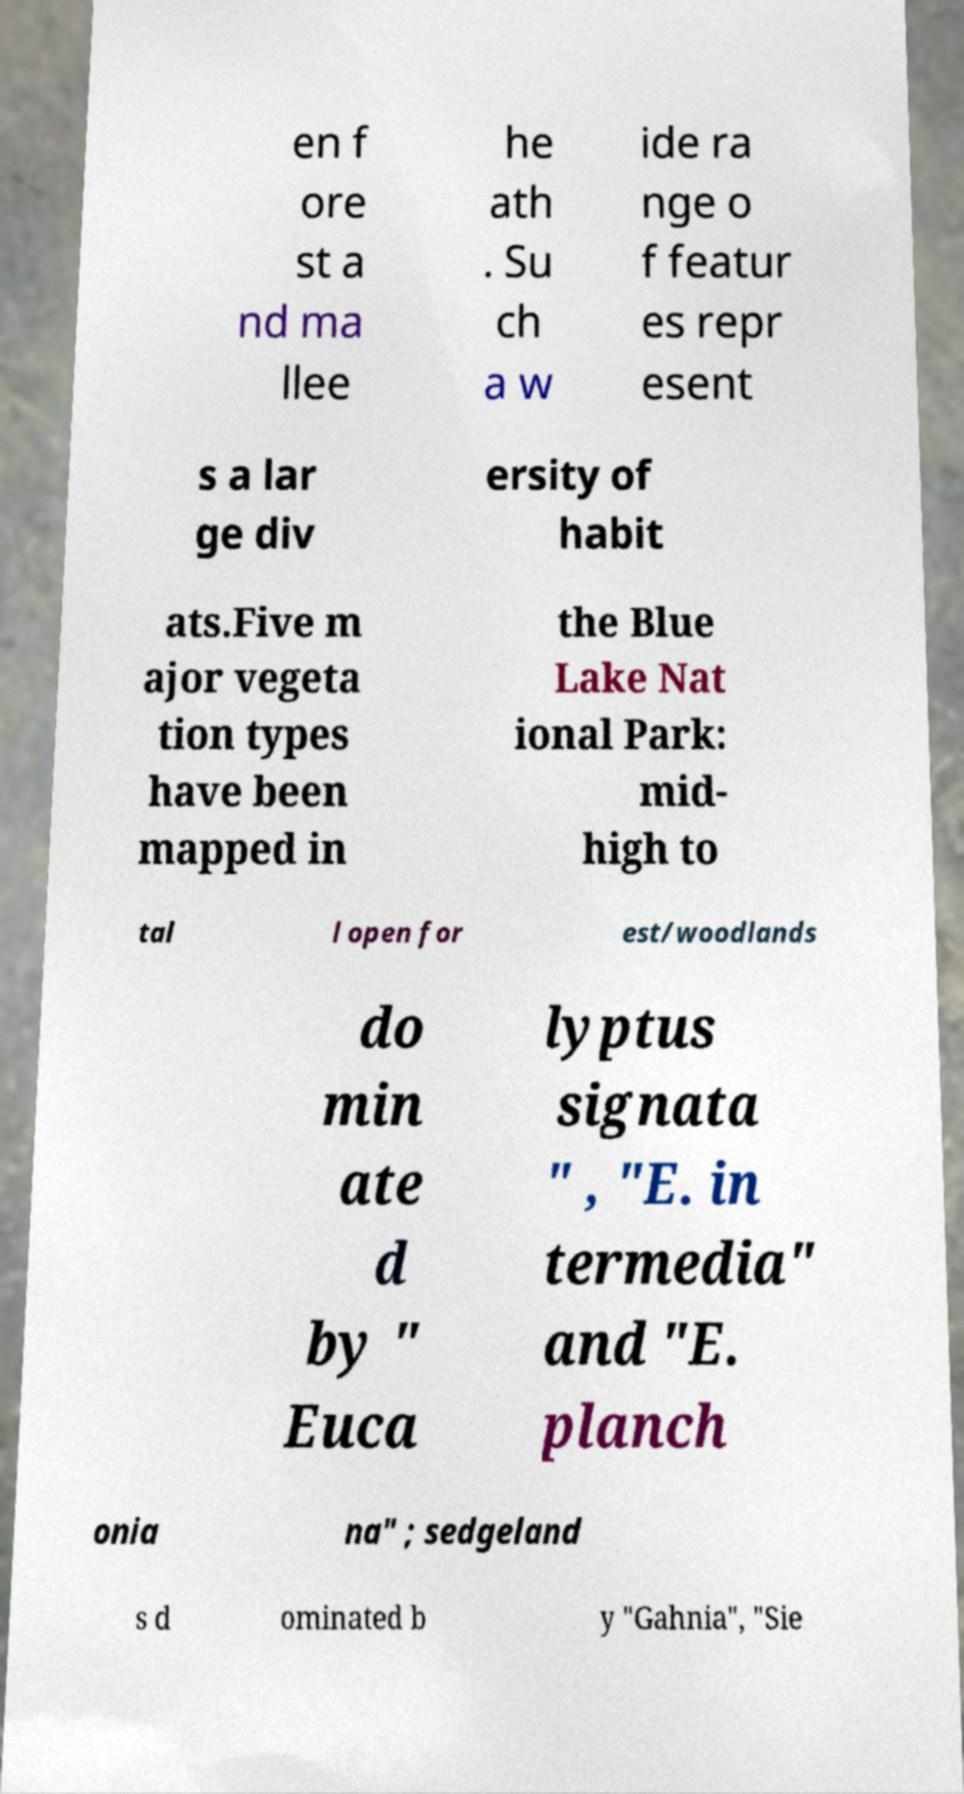Please read and relay the text visible in this image. What does it say? en f ore st a nd ma llee he ath . Su ch a w ide ra nge o f featur es repr esent s a lar ge div ersity of habit ats.Five m ajor vegeta tion types have been mapped in the Blue Lake Nat ional Park: mid- high to tal l open for est/woodlands do min ate d by " Euca lyptus signata " , "E. in termedia" and "E. planch onia na" ; sedgeland s d ominated b y "Gahnia", "Sie 